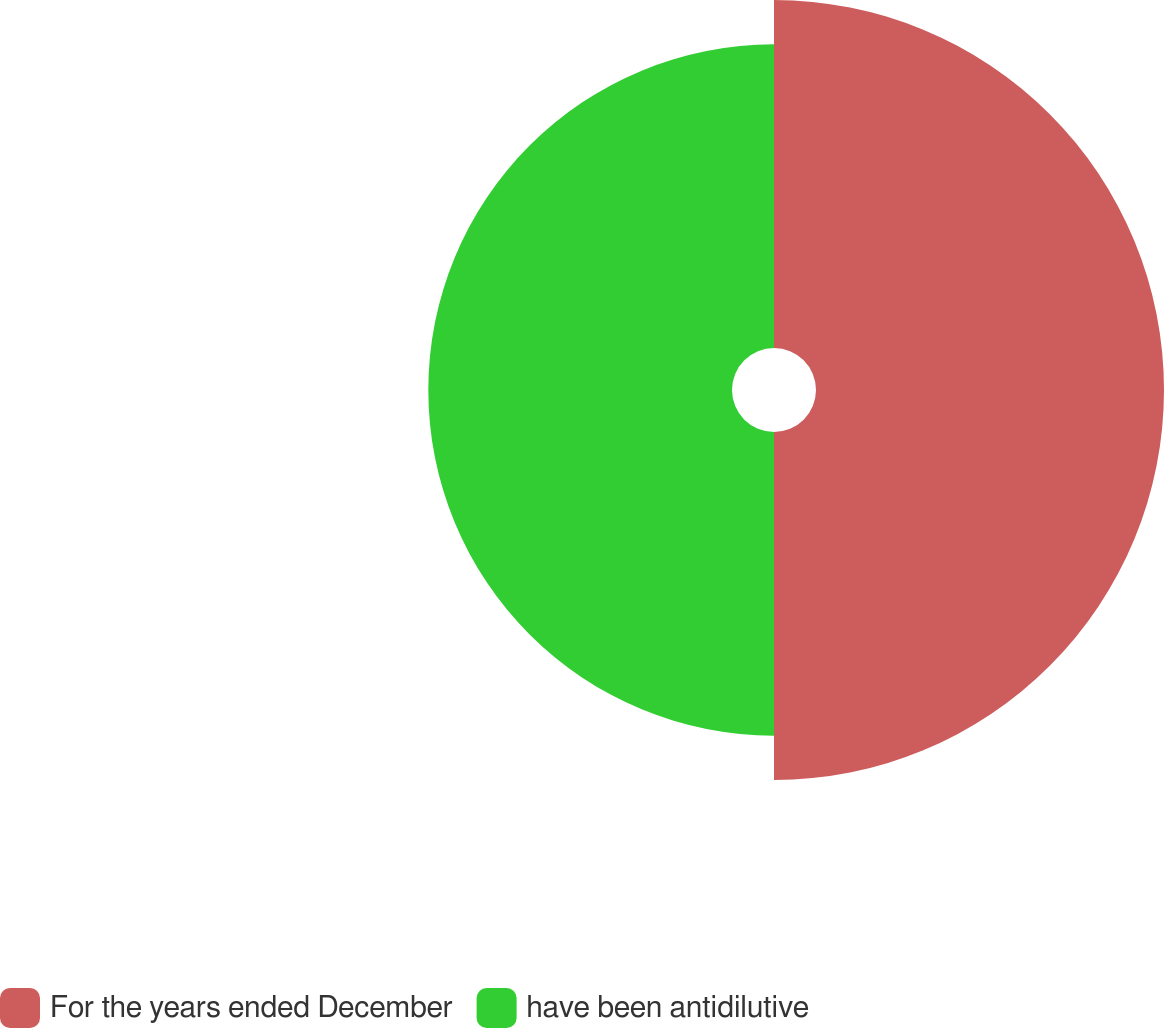Convert chart to OTSL. <chart><loc_0><loc_0><loc_500><loc_500><pie_chart><fcel>For the years ended December<fcel>have been antidilutive<nl><fcel>53.4%<fcel>46.6%<nl></chart> 